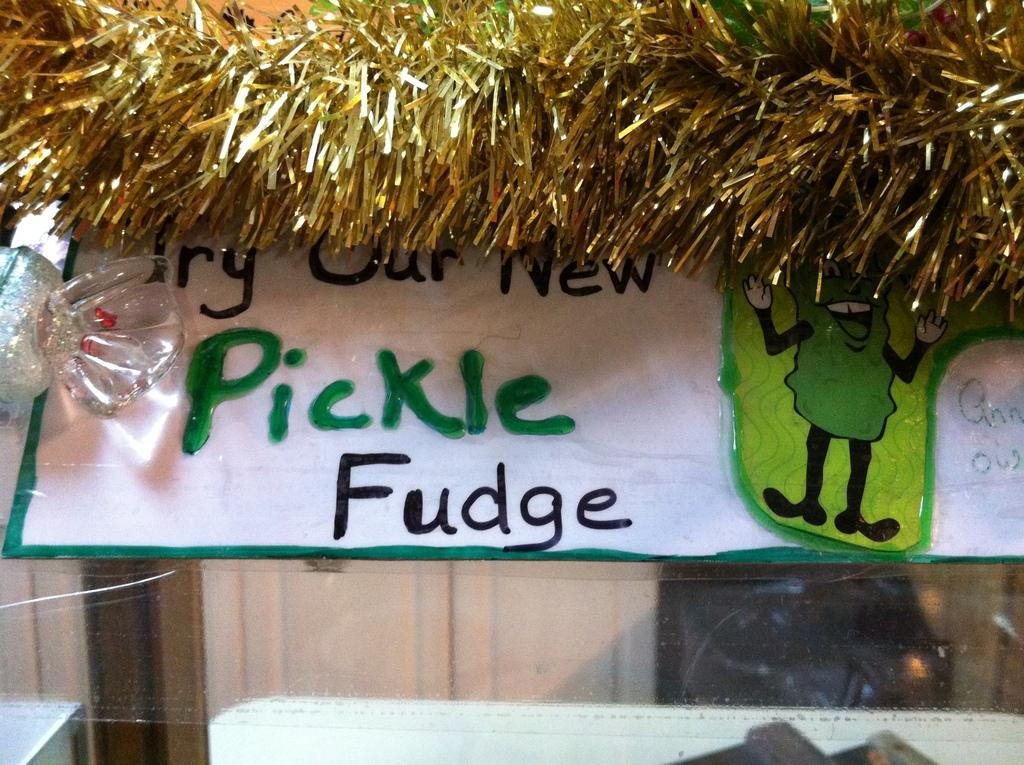What is hanging or displayed in the image? There is a banner in the image. What other items can be seen in the image besides the banner? There are decorative items in the image. What is visible in the background of the image? There is a wall in the image. Can you see the ocean in the image? There is no ocean visible in the image. Is there an arch present in the image? There is no arch present in the image. 